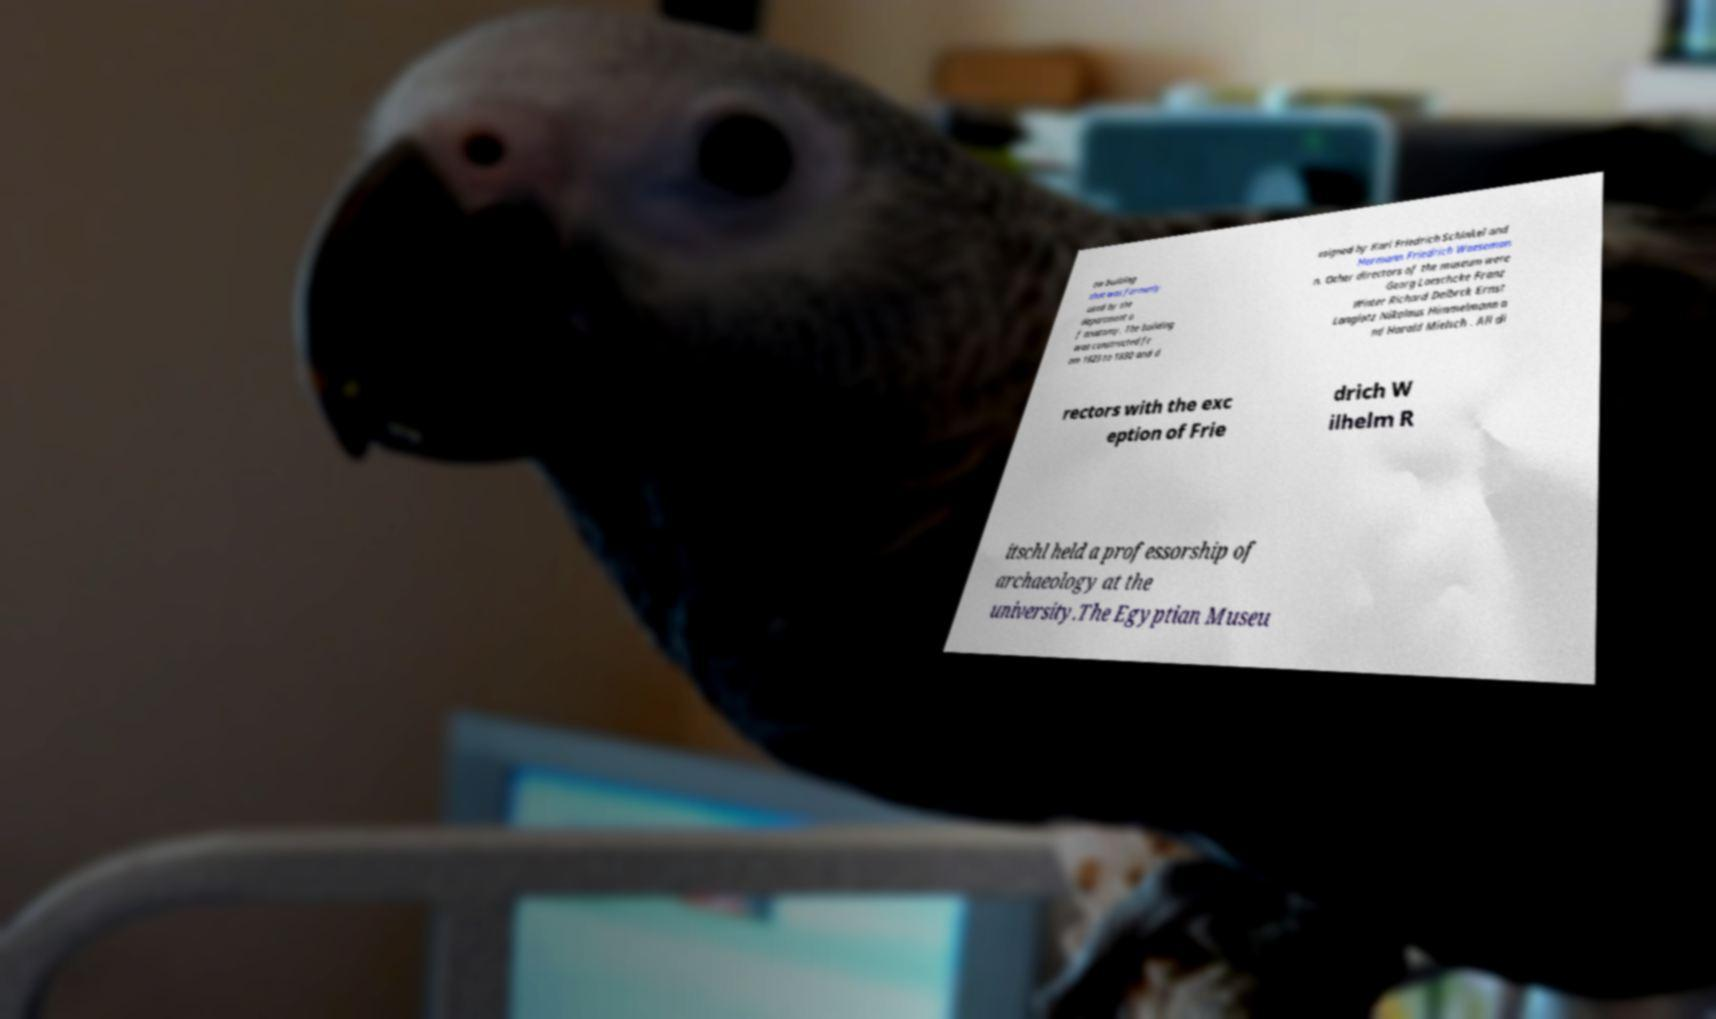Can you accurately transcribe the text from the provided image for me? ew building that was formerly used by the department o f anatomy. The building was constructed fr om 1823 to 1830 and d esigned by Karl Friedrich Schinkel and Hermann Friedrich Waeseman n. Other directors of the museum were Georg Loeschcke Franz Winter Richard Delbrck Ernst Langlotz Nikolaus Himmelmann a nd Harald Mielsch . All di rectors with the exc eption of Frie drich W ilhelm R itschl held a professorship of archaeology at the university.The Egyptian Museu 